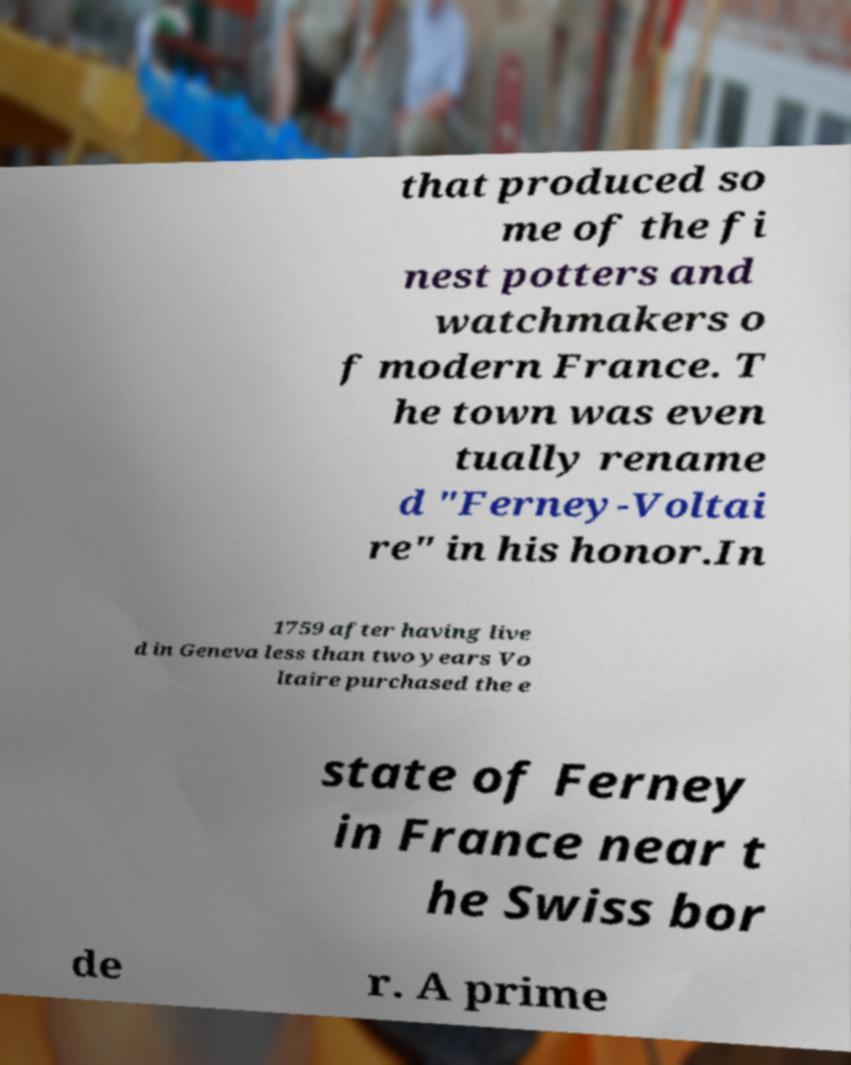Can you accurately transcribe the text from the provided image for me? that produced so me of the fi nest potters and watchmakers o f modern France. T he town was even tually rename d "Ferney-Voltai re" in his honor.In 1759 after having live d in Geneva less than two years Vo ltaire purchased the e state of Ferney in France near t he Swiss bor de r. A prime 